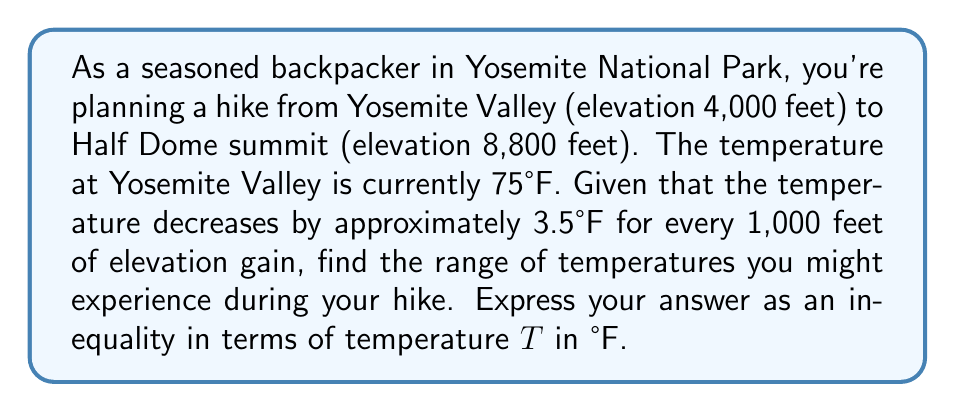Can you answer this question? Let's approach this step-by-step:

1) First, calculate the total elevation gain:
   $8,800 - 4,000 = 4,800$ feet

2) Now, determine the total temperature decrease:
   $\frac{4,800 \text{ feet}}{1,000 \text{ feet}} \times 3.5°\text{F} = 16.8°\text{F}$

3) The lowest temperature will be at the summit of Half Dome:
   $75°\text{F} - 16.8°\text{F} = 58.2°\text{F}$

4) Therefore, the range of temperatures will be from 58.2°F to 75°F.

5) We can express this as an inequality:
   $58.2 \leq T \leq 75$

   Where T represents the temperature in °F.
Answer: $58.2 \leq T \leq 75$ 